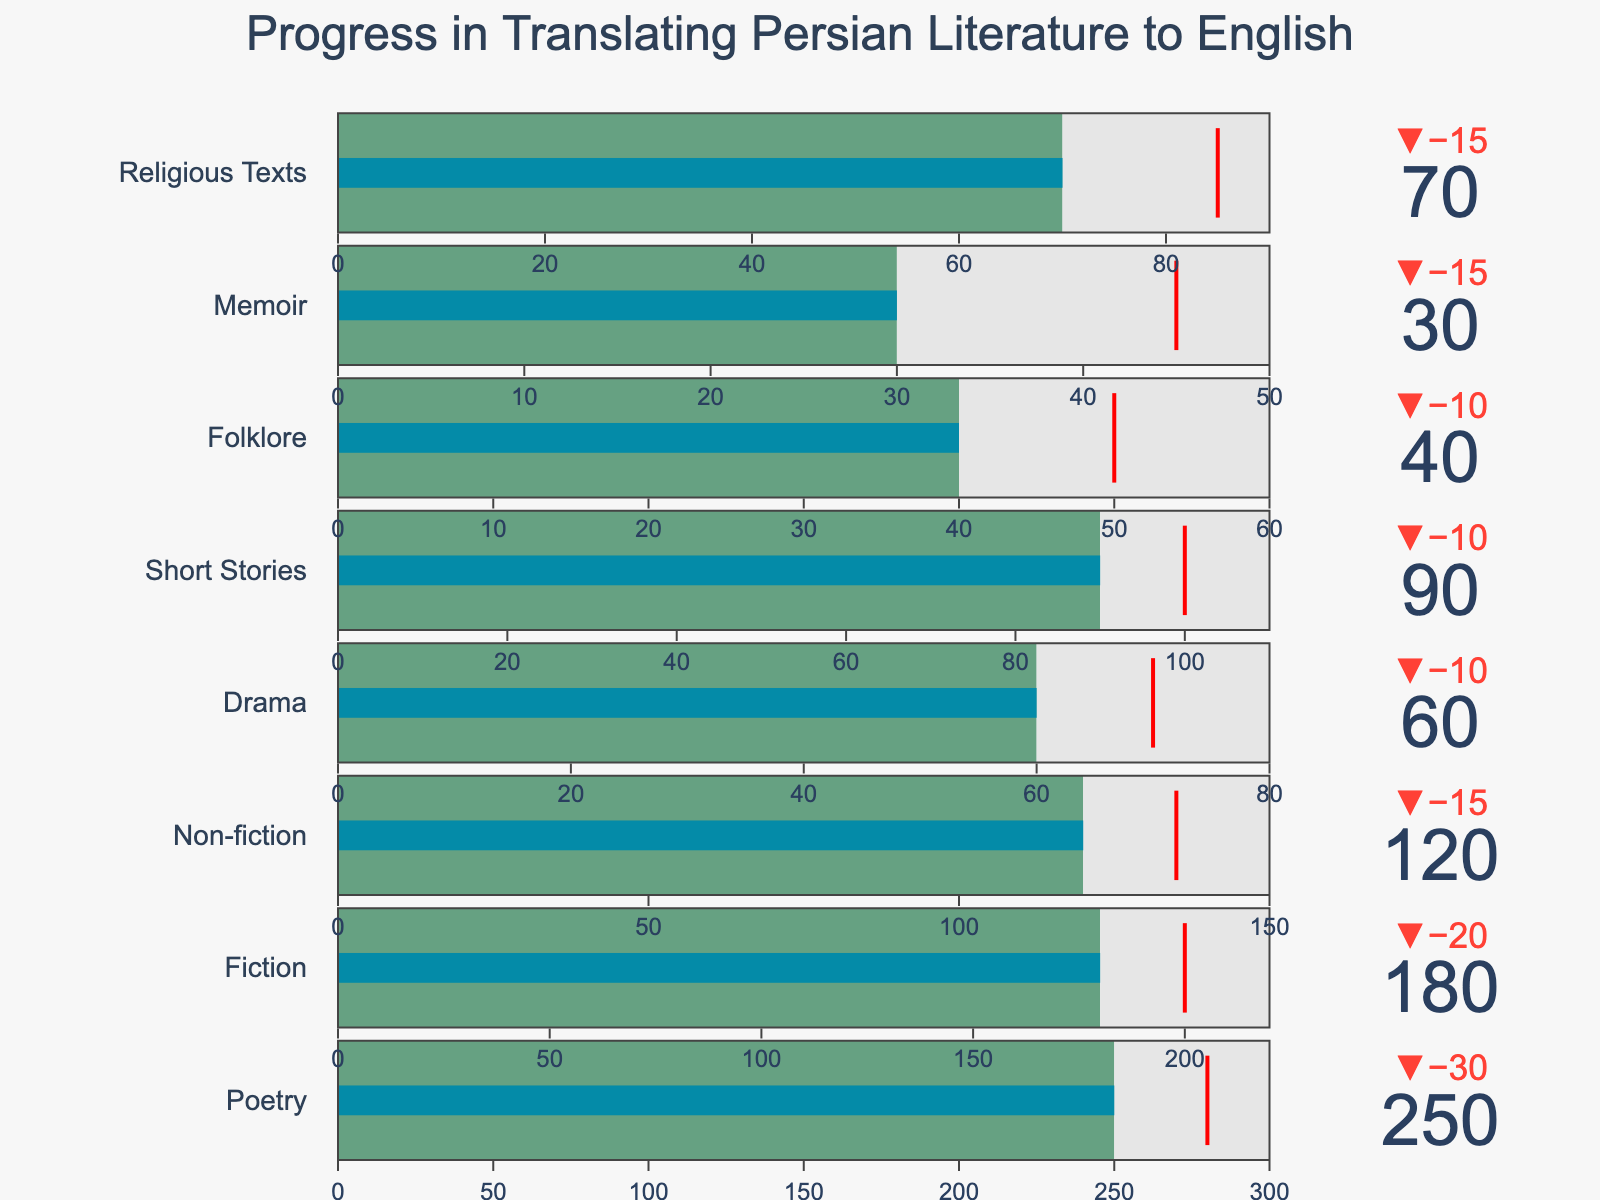What's the total target for all genres combined? Sum up the individual target values for each genre: 300 (Poetry) + 220 (Fiction) + 150 (Non-fiction) + 80 (Drama) + 110 (Short Stories) + 60 (Folklore) + 50 (Memoir) + 90 (Religious Texts) = 1060
Answer: 1060 Which genre has the highest translated value? Compare the translated values for each genre and identify the highest: Poetry with 250
Answer: Poetry For which genre is the difference between the translated value and the target the smallest? Calculate the difference between the translated value and the target for each genre: 
Poetry: 50 (300 - 250), Fiction: 40 (220 - 180), Non-fiction: 30 (150 - 120), Drama: 20 (80 - 60), Short Stories: 20 (110 - 90), Folklore: 20 (60 - 40), Memoir: 20 (50 - 30), Religious Texts: 20 (90 - 70). The minimum difference (20) is between Drama, Short Stories, Folklore, Memoir, and Religious Texts.
Answer: Drama, Short Stories, Folklore, Memoir, Religious Texts What is the comparative value for Fiction? Look at the comparative column value for the Fiction genre: 200
Answer: 200 How does the translated value for Memoir compare to its comparative value? Compare the translated (30) and comparative (45) values for Memoir: 30 is less than 45
Answer: 30 is less than 45 Which genre has the highest comparative value? Identify the maximum value from the comparative column: Poetry with 280
Answer: Poetry How much more translated work is needed for Folklore to meet the target? Subtract the translated value from the target value for Folklore: 60 - 40 = 20
Answer: 20 Which genre has exceeded its comparative value by the largest margin? Calculate the difference between translated and comparative values for each genre where translated exceeds comparative:
Poetry: 250 - 280 = -30, Fiction: 180 - 200 = -20, 
Non-fiction: 120 - 135 = -15, Drama: 60 - 70 = -10,
Short Stories: 90 - 100 = -10, Folklore: 40 - 50 = -10, 
Memoir: 30 - 45 = -15, Religious Texts: 70 - 85 = -15.
No genre has exceeded its comparative value.
Answer: None What is the threshold value for Non-fiction in this chart? Look for the threshold value set for Non-fiction: 135
Answer: 135 